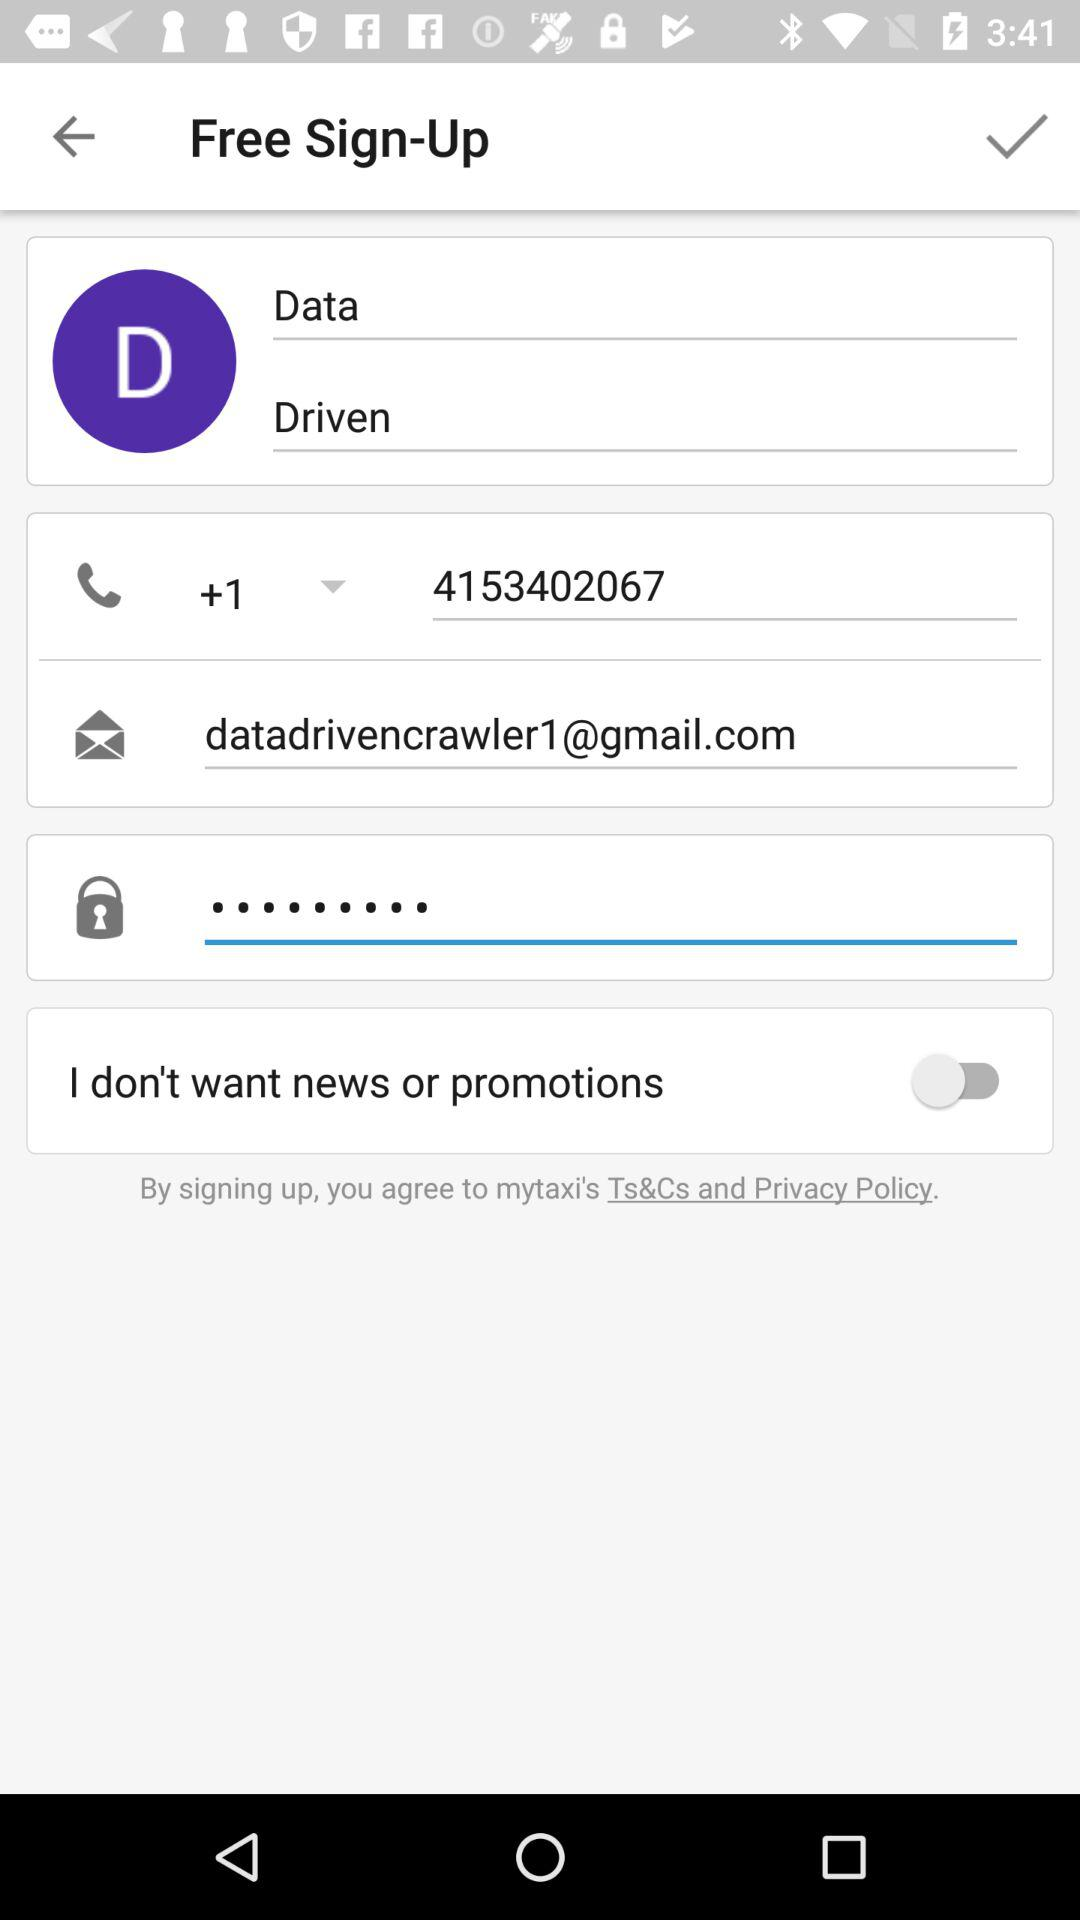What is the name of the user? The name of the user is Data Driven. 